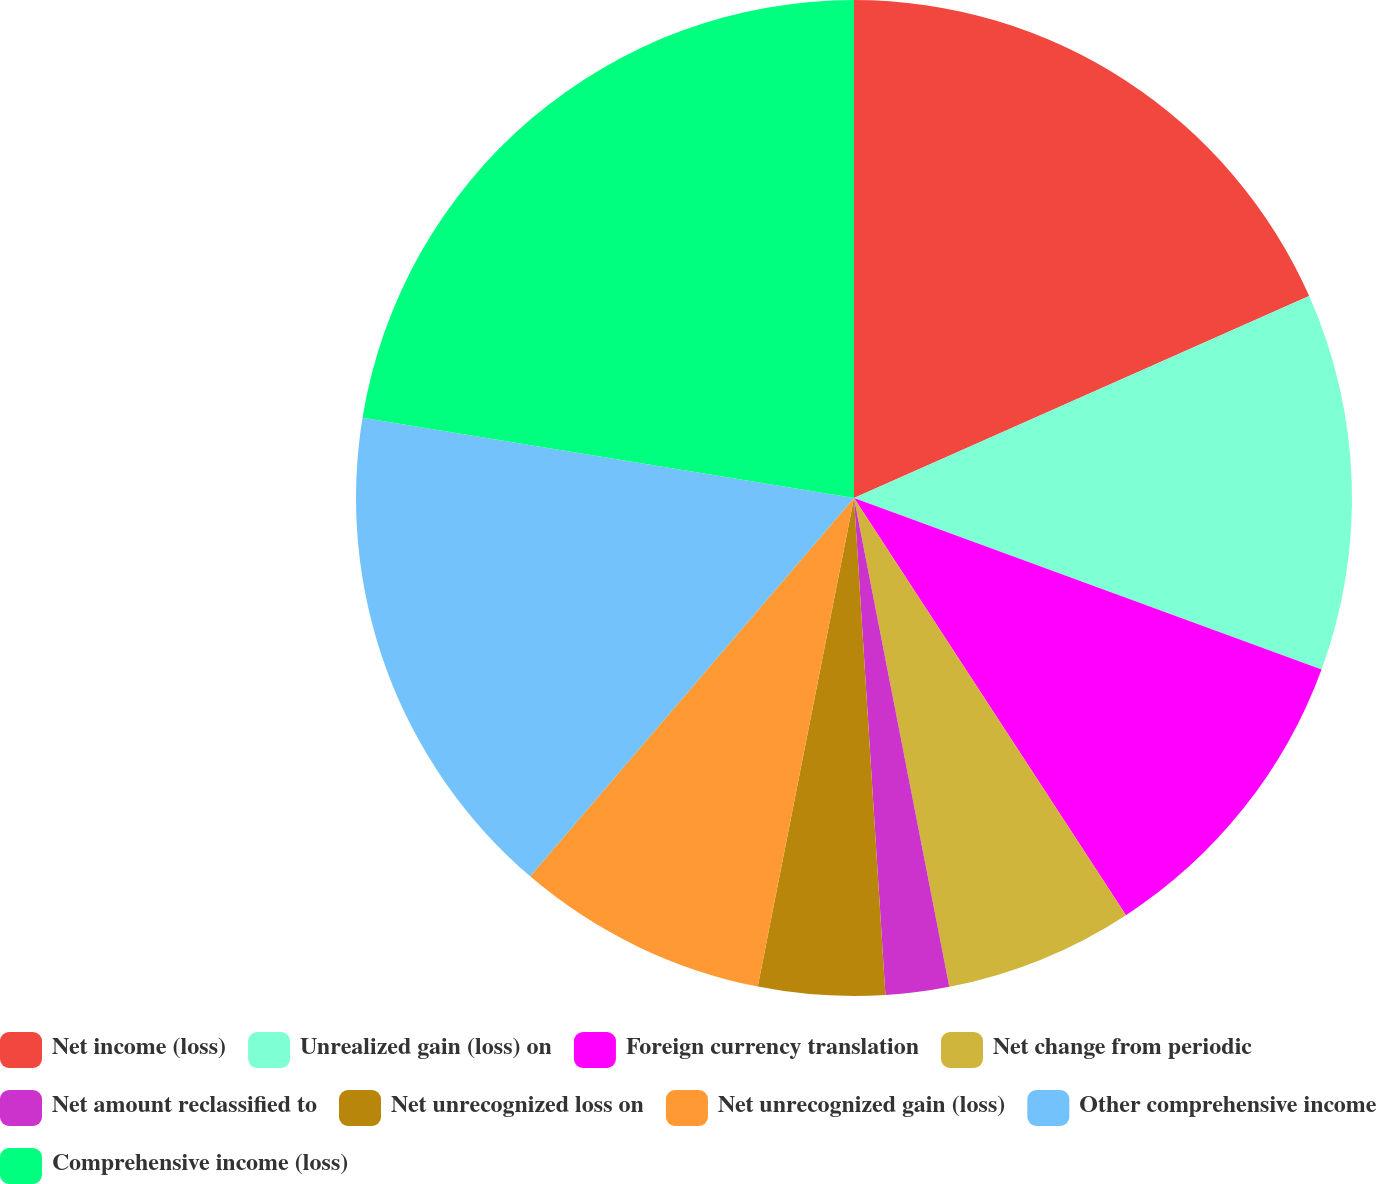Convert chart to OTSL. <chart><loc_0><loc_0><loc_500><loc_500><pie_chart><fcel>Net income (loss)<fcel>Unrealized gain (loss) on<fcel>Foreign currency translation<fcel>Net change from periodic<fcel>Net amount reclassified to<fcel>Net unrecognized loss on<fcel>Net unrecognized gain (loss)<fcel>Other comprehensive income<fcel>Comprehensive income (loss)<nl><fcel>18.35%<fcel>12.24%<fcel>10.21%<fcel>6.13%<fcel>2.06%<fcel>4.1%<fcel>8.17%<fcel>16.31%<fcel>22.42%<nl></chart> 